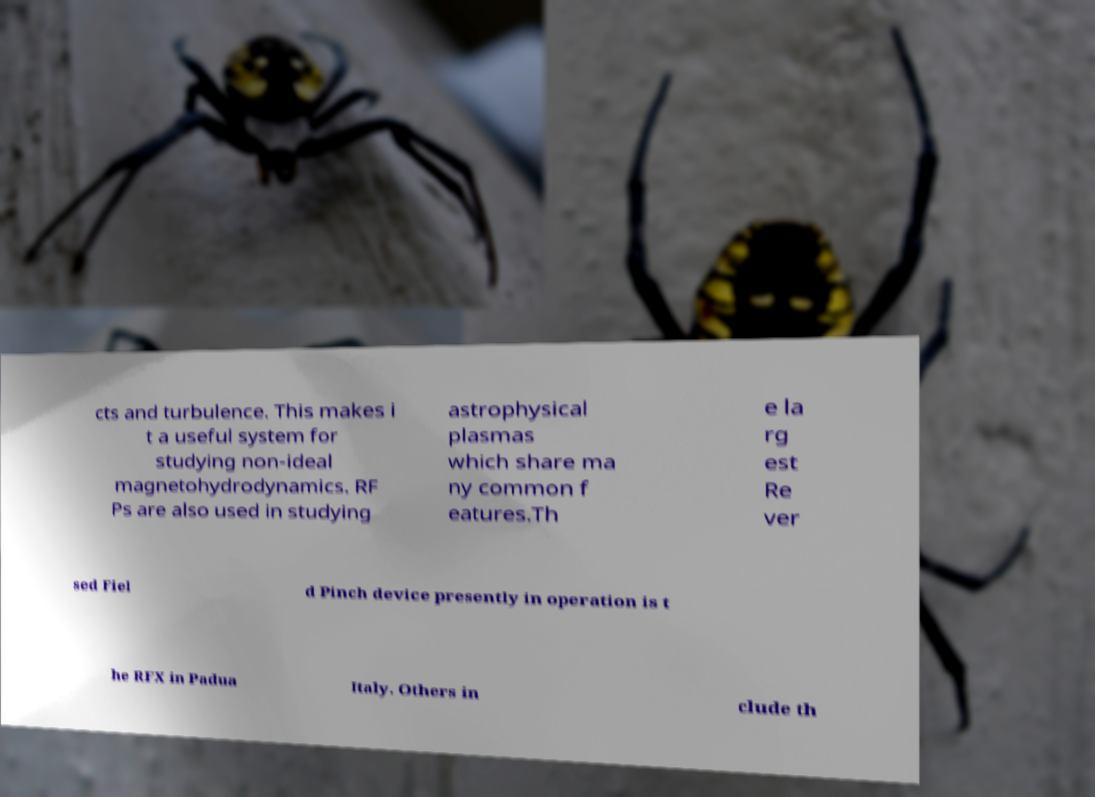Can you accurately transcribe the text from the provided image for me? cts and turbulence. This makes i t a useful system for studying non-ideal magnetohydrodynamics. RF Ps are also used in studying astrophysical plasmas which share ma ny common f eatures.Th e la rg est Re ver sed Fiel d Pinch device presently in operation is t he RFX in Padua Italy. Others in clude th 